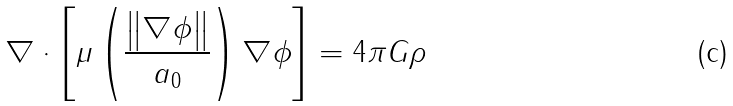Convert formula to latex. <formula><loc_0><loc_0><loc_500><loc_500>\nabla \cdot \left [ \mu \left ( { \frac { \left \| \nabla \phi \right \| } { a _ { 0 } } } \right ) \nabla \phi \right ] = 4 \pi G \rho</formula> 